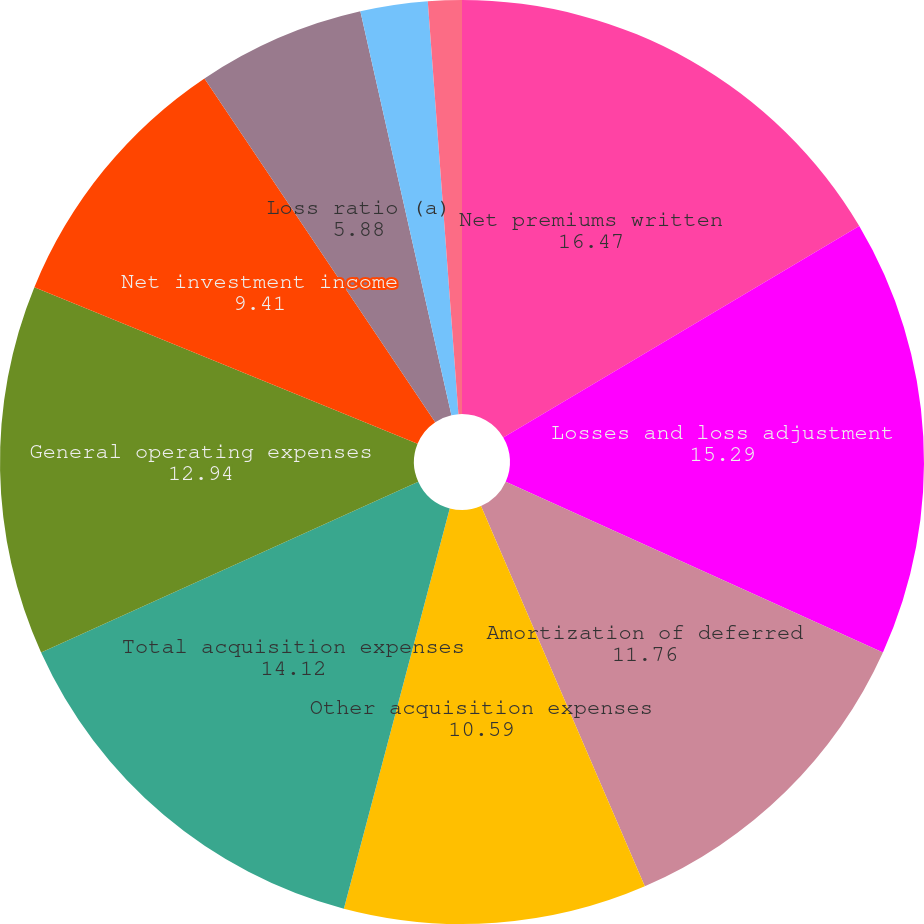Convert chart. <chart><loc_0><loc_0><loc_500><loc_500><pie_chart><fcel>Net premiums written<fcel>Losses and loss adjustment<fcel>Amortization of deferred<fcel>Other acquisition expenses<fcel>Total acquisition expenses<fcel>General operating expenses<fcel>Net investment income<fcel>Loss ratio (a)<fcel>Acquisition ratio<fcel>General operating expense<nl><fcel>16.47%<fcel>15.29%<fcel>11.76%<fcel>10.59%<fcel>14.12%<fcel>12.94%<fcel>9.41%<fcel>5.88%<fcel>2.35%<fcel>1.18%<nl></chart> 